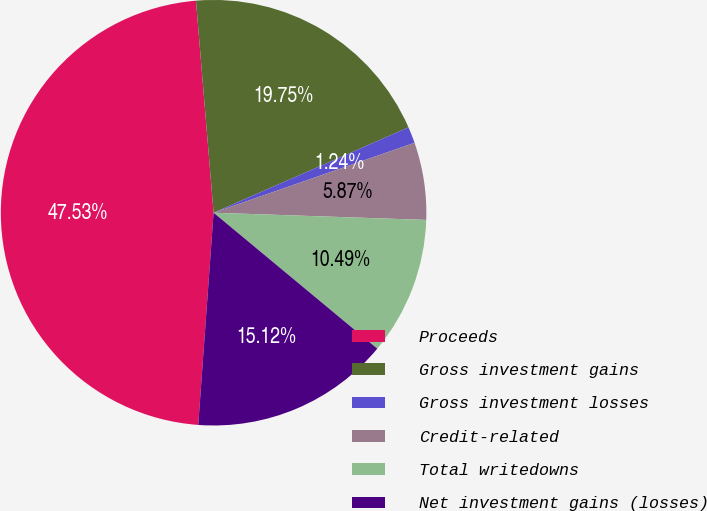<chart> <loc_0><loc_0><loc_500><loc_500><pie_chart><fcel>Proceeds<fcel>Gross investment gains<fcel>Gross investment losses<fcel>Credit-related<fcel>Total writedowns<fcel>Net investment gains (losses)<nl><fcel>47.53%<fcel>19.75%<fcel>1.24%<fcel>5.87%<fcel>10.49%<fcel>15.12%<nl></chart> 